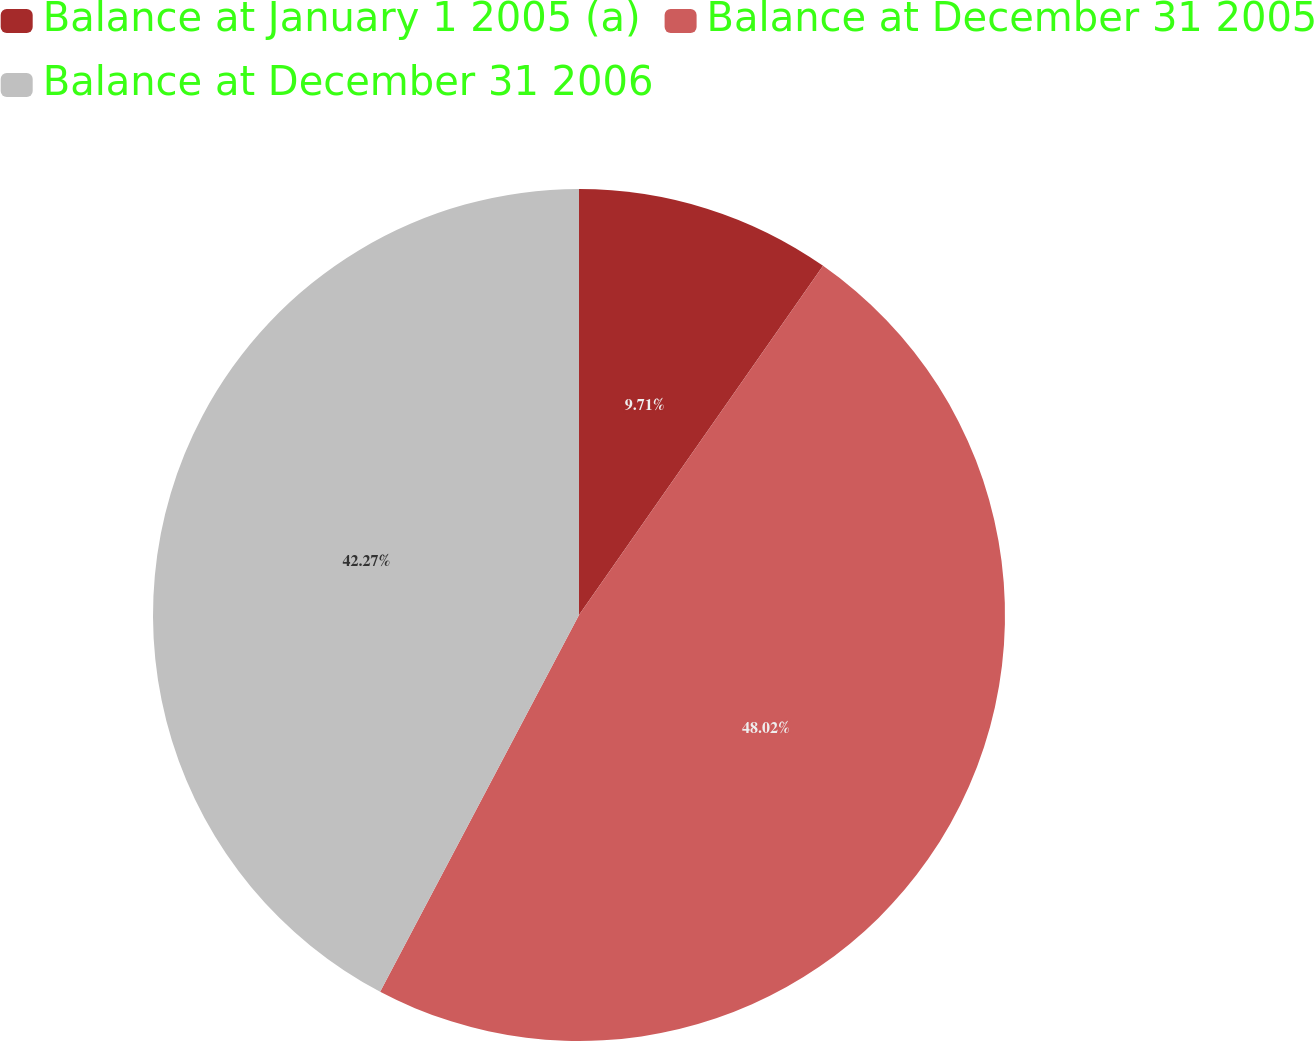<chart> <loc_0><loc_0><loc_500><loc_500><pie_chart><fcel>Balance at January 1 2005 (a)<fcel>Balance at December 31 2005<fcel>Balance at December 31 2006<nl><fcel>9.71%<fcel>48.02%<fcel>42.27%<nl></chart> 